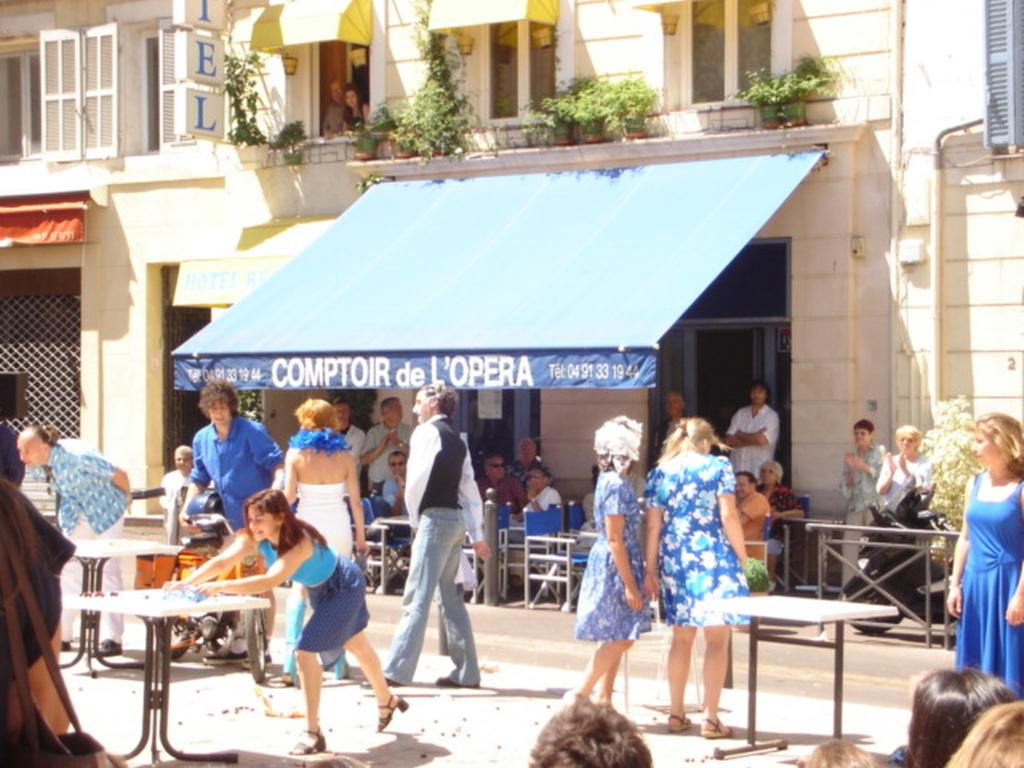What is happening in the street in the image? There are people in the street in the image. What can be seen in the background of the image? There is a store and a building in the background of the image. How many boxes can be seen in the image? There are no boxes present in the image. Are the people in the street slipping on anything in the image? There is no indication in the image that the people are slipping on anything. 